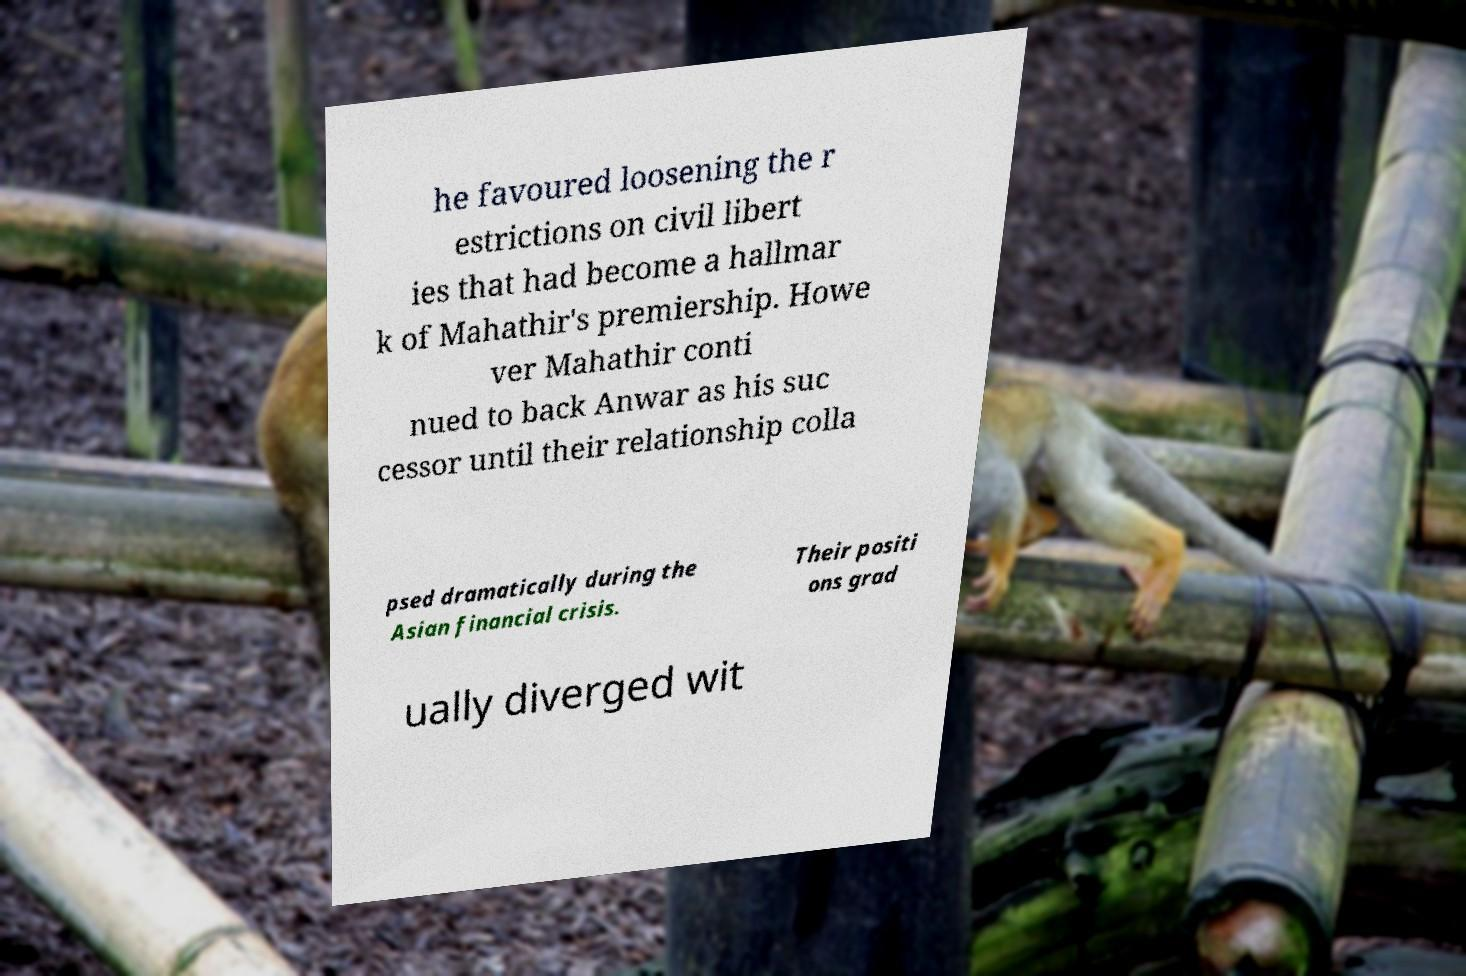There's text embedded in this image that I need extracted. Can you transcribe it verbatim? he favoured loosening the r estrictions on civil libert ies that had become a hallmar k of Mahathir's premiership. Howe ver Mahathir conti nued to back Anwar as his suc cessor until their relationship colla psed dramatically during the Asian financial crisis. Their positi ons grad ually diverged wit 